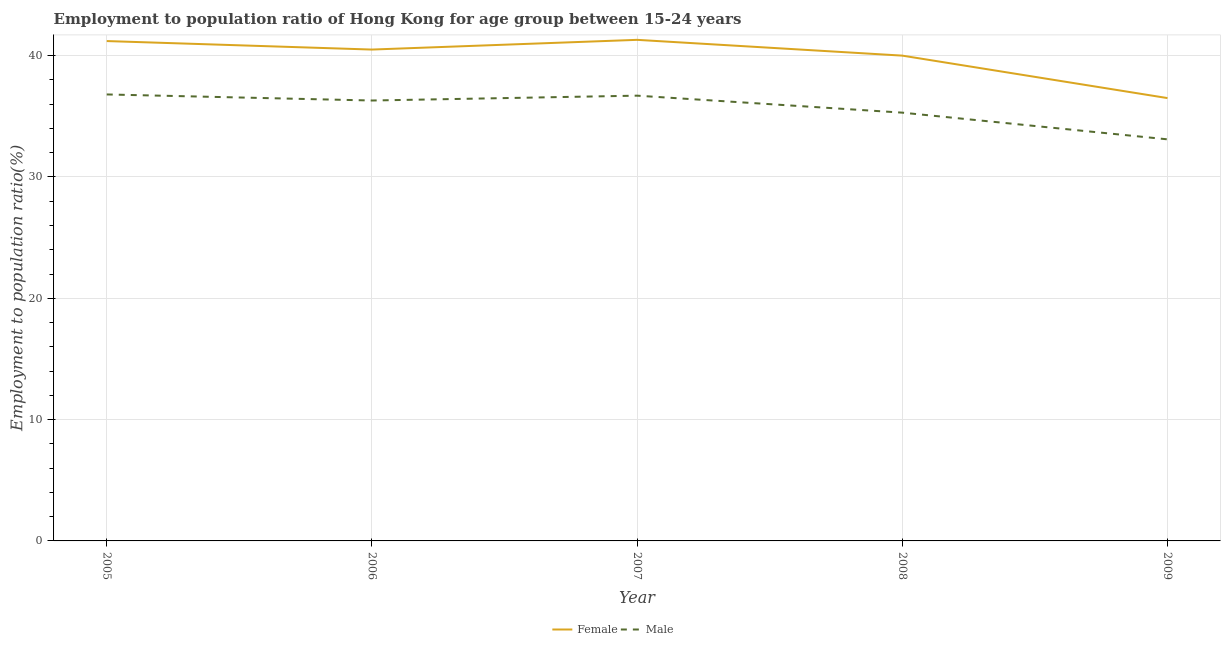Is the number of lines equal to the number of legend labels?
Your answer should be very brief. Yes. What is the employment to population ratio(male) in 2006?
Your response must be concise. 36.3. Across all years, what is the maximum employment to population ratio(female)?
Your answer should be very brief. 41.3. Across all years, what is the minimum employment to population ratio(male)?
Offer a very short reply. 33.1. In which year was the employment to population ratio(female) minimum?
Your answer should be compact. 2009. What is the total employment to population ratio(male) in the graph?
Provide a short and direct response. 178.2. What is the difference between the employment to population ratio(male) in 2008 and that in 2009?
Keep it short and to the point. 2.2. What is the difference between the employment to population ratio(female) in 2009 and the employment to population ratio(male) in 2006?
Your answer should be very brief. 0.2. What is the average employment to population ratio(female) per year?
Your answer should be very brief. 39.9. In the year 2007, what is the difference between the employment to population ratio(female) and employment to population ratio(male)?
Offer a very short reply. 4.6. In how many years, is the employment to population ratio(female) greater than 16 %?
Make the answer very short. 5. What is the ratio of the employment to population ratio(female) in 2006 to that in 2009?
Your response must be concise. 1.11. Is the employment to population ratio(female) in 2005 less than that in 2007?
Offer a terse response. Yes. What is the difference between the highest and the second highest employment to population ratio(male)?
Offer a terse response. 0.1. What is the difference between the highest and the lowest employment to population ratio(female)?
Offer a very short reply. 4.8. In how many years, is the employment to population ratio(female) greater than the average employment to population ratio(female) taken over all years?
Keep it short and to the point. 4. How many lines are there?
Offer a very short reply. 2. What is the difference between two consecutive major ticks on the Y-axis?
Your response must be concise. 10. Does the graph contain grids?
Your answer should be very brief. Yes. Where does the legend appear in the graph?
Keep it short and to the point. Bottom center. How many legend labels are there?
Make the answer very short. 2. What is the title of the graph?
Keep it short and to the point. Employment to population ratio of Hong Kong for age group between 15-24 years. Does "% of GNI" appear as one of the legend labels in the graph?
Your response must be concise. No. What is the label or title of the Y-axis?
Give a very brief answer. Employment to population ratio(%). What is the Employment to population ratio(%) in Female in 2005?
Your answer should be very brief. 41.2. What is the Employment to population ratio(%) in Male in 2005?
Provide a succinct answer. 36.8. What is the Employment to population ratio(%) of Female in 2006?
Make the answer very short. 40.5. What is the Employment to population ratio(%) of Male in 2006?
Your answer should be very brief. 36.3. What is the Employment to population ratio(%) of Female in 2007?
Your response must be concise. 41.3. What is the Employment to population ratio(%) of Male in 2007?
Offer a very short reply. 36.7. What is the Employment to population ratio(%) of Male in 2008?
Your answer should be compact. 35.3. What is the Employment to population ratio(%) of Female in 2009?
Make the answer very short. 36.5. What is the Employment to population ratio(%) in Male in 2009?
Provide a short and direct response. 33.1. Across all years, what is the maximum Employment to population ratio(%) in Female?
Provide a short and direct response. 41.3. Across all years, what is the maximum Employment to population ratio(%) in Male?
Make the answer very short. 36.8. Across all years, what is the minimum Employment to population ratio(%) of Female?
Give a very brief answer. 36.5. Across all years, what is the minimum Employment to population ratio(%) in Male?
Give a very brief answer. 33.1. What is the total Employment to population ratio(%) in Female in the graph?
Offer a terse response. 199.5. What is the total Employment to population ratio(%) in Male in the graph?
Your response must be concise. 178.2. What is the difference between the Employment to population ratio(%) in Female in 2005 and that in 2007?
Your answer should be compact. -0.1. What is the difference between the Employment to population ratio(%) in Male in 2005 and that in 2008?
Give a very brief answer. 1.5. What is the difference between the Employment to population ratio(%) in Female in 2005 and that in 2009?
Provide a short and direct response. 4.7. What is the difference between the Employment to population ratio(%) in Female in 2006 and that in 2007?
Offer a very short reply. -0.8. What is the difference between the Employment to population ratio(%) of Male in 2006 and that in 2007?
Provide a succinct answer. -0.4. What is the difference between the Employment to population ratio(%) of Female in 2007 and that in 2008?
Give a very brief answer. 1.3. What is the difference between the Employment to population ratio(%) of Male in 2007 and that in 2008?
Give a very brief answer. 1.4. What is the difference between the Employment to population ratio(%) in Female in 2007 and that in 2009?
Ensure brevity in your answer.  4.8. What is the difference between the Employment to population ratio(%) in Male in 2008 and that in 2009?
Provide a short and direct response. 2.2. What is the difference between the Employment to population ratio(%) of Female in 2005 and the Employment to population ratio(%) of Male in 2006?
Your response must be concise. 4.9. What is the difference between the Employment to population ratio(%) in Female in 2005 and the Employment to population ratio(%) in Male in 2008?
Offer a very short reply. 5.9. What is the difference between the Employment to population ratio(%) in Female in 2006 and the Employment to population ratio(%) in Male in 2008?
Your answer should be very brief. 5.2. What is the difference between the Employment to population ratio(%) in Female in 2007 and the Employment to population ratio(%) in Male in 2008?
Keep it short and to the point. 6. What is the difference between the Employment to population ratio(%) of Female in 2007 and the Employment to population ratio(%) of Male in 2009?
Make the answer very short. 8.2. What is the average Employment to population ratio(%) in Female per year?
Offer a terse response. 39.9. What is the average Employment to population ratio(%) of Male per year?
Offer a terse response. 35.64. In the year 2006, what is the difference between the Employment to population ratio(%) in Female and Employment to population ratio(%) in Male?
Provide a short and direct response. 4.2. In the year 2008, what is the difference between the Employment to population ratio(%) in Female and Employment to population ratio(%) in Male?
Your response must be concise. 4.7. In the year 2009, what is the difference between the Employment to population ratio(%) in Female and Employment to population ratio(%) in Male?
Provide a short and direct response. 3.4. What is the ratio of the Employment to population ratio(%) in Female in 2005 to that in 2006?
Your answer should be very brief. 1.02. What is the ratio of the Employment to population ratio(%) in Male in 2005 to that in 2006?
Give a very brief answer. 1.01. What is the ratio of the Employment to population ratio(%) in Female in 2005 to that in 2008?
Offer a terse response. 1.03. What is the ratio of the Employment to population ratio(%) of Male in 2005 to that in 2008?
Ensure brevity in your answer.  1.04. What is the ratio of the Employment to population ratio(%) in Female in 2005 to that in 2009?
Keep it short and to the point. 1.13. What is the ratio of the Employment to population ratio(%) in Male in 2005 to that in 2009?
Give a very brief answer. 1.11. What is the ratio of the Employment to population ratio(%) in Female in 2006 to that in 2007?
Offer a terse response. 0.98. What is the ratio of the Employment to population ratio(%) in Female in 2006 to that in 2008?
Offer a very short reply. 1.01. What is the ratio of the Employment to population ratio(%) in Male in 2006 to that in 2008?
Keep it short and to the point. 1.03. What is the ratio of the Employment to population ratio(%) in Female in 2006 to that in 2009?
Keep it short and to the point. 1.11. What is the ratio of the Employment to population ratio(%) of Male in 2006 to that in 2009?
Ensure brevity in your answer.  1.1. What is the ratio of the Employment to population ratio(%) of Female in 2007 to that in 2008?
Make the answer very short. 1.03. What is the ratio of the Employment to population ratio(%) in Male in 2007 to that in 2008?
Your response must be concise. 1.04. What is the ratio of the Employment to population ratio(%) of Female in 2007 to that in 2009?
Offer a very short reply. 1.13. What is the ratio of the Employment to population ratio(%) in Male in 2007 to that in 2009?
Your answer should be very brief. 1.11. What is the ratio of the Employment to population ratio(%) in Female in 2008 to that in 2009?
Provide a succinct answer. 1.1. What is the ratio of the Employment to population ratio(%) in Male in 2008 to that in 2009?
Provide a succinct answer. 1.07. What is the difference between the highest and the second highest Employment to population ratio(%) of Male?
Make the answer very short. 0.1. 